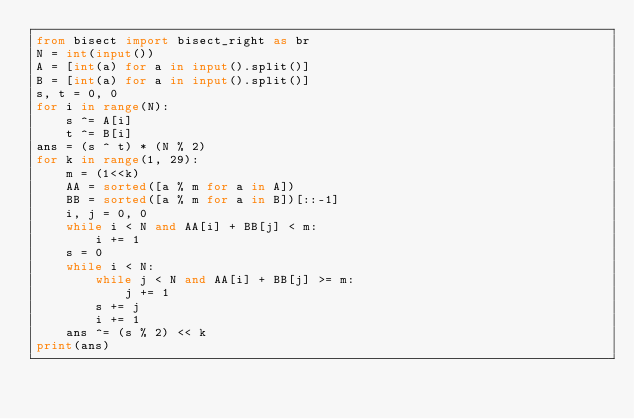<code> <loc_0><loc_0><loc_500><loc_500><_Python_>from bisect import bisect_right as br
N = int(input())
A = [int(a) for a in input().split()]
B = [int(a) for a in input().split()]
s, t = 0, 0
for i in range(N):
    s ^= A[i]
    t ^= B[i]
ans = (s ^ t) * (N % 2)
for k in range(1, 29):
    m = (1<<k)
    AA = sorted([a % m for a in A])
    BB = sorted([a % m for a in B])[::-1]
    i, j = 0, 0
    while i < N and AA[i] + BB[j] < m:
        i += 1
    s = 0
    while i < N:
        while j < N and AA[i] + BB[j] >= m:
            j += 1
        s += j
        i += 1
    ans ^= (s % 2) << k
print(ans)</code> 